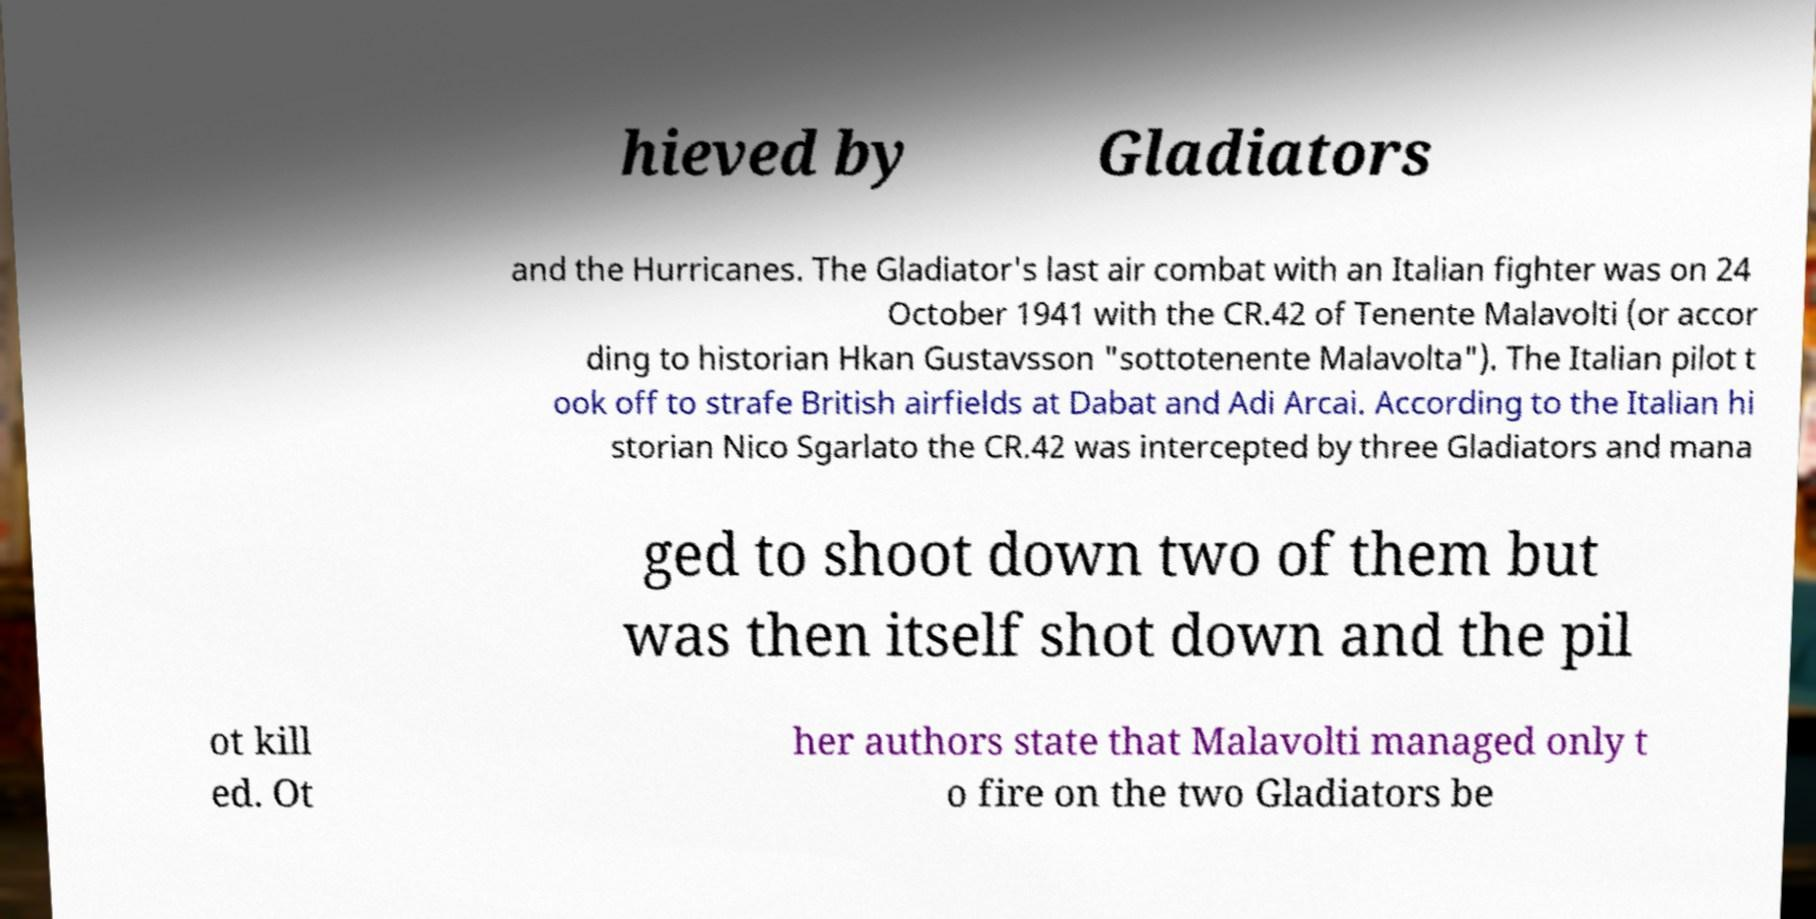There's text embedded in this image that I need extracted. Can you transcribe it verbatim? hieved by Gladiators and the Hurricanes. The Gladiator's last air combat with an Italian fighter was on 24 October 1941 with the CR.42 of Tenente Malavolti (or accor ding to historian Hkan Gustavsson "sottotenente Malavolta"). The Italian pilot t ook off to strafe British airfields at Dabat and Adi Arcai. According to the Italian hi storian Nico Sgarlato the CR.42 was intercepted by three Gladiators and mana ged to shoot down two of them but was then itself shot down and the pil ot kill ed. Ot her authors state that Malavolti managed only t o fire on the two Gladiators be 